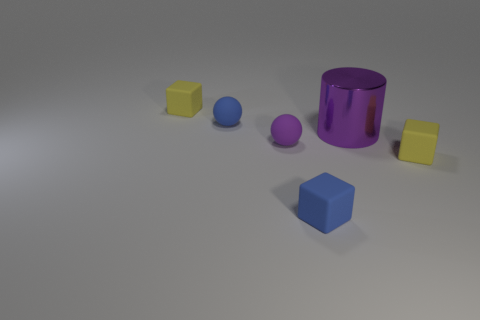Subtract all small blue blocks. How many blocks are left? 2 Add 3 tiny brown cylinders. How many objects exist? 9 Subtract all spheres. How many objects are left? 4 Subtract 0 blue cylinders. How many objects are left? 6 Subtract all tiny red shiny blocks. Subtract all matte things. How many objects are left? 1 Add 2 purple cylinders. How many purple cylinders are left? 3 Add 1 purple objects. How many purple objects exist? 3 